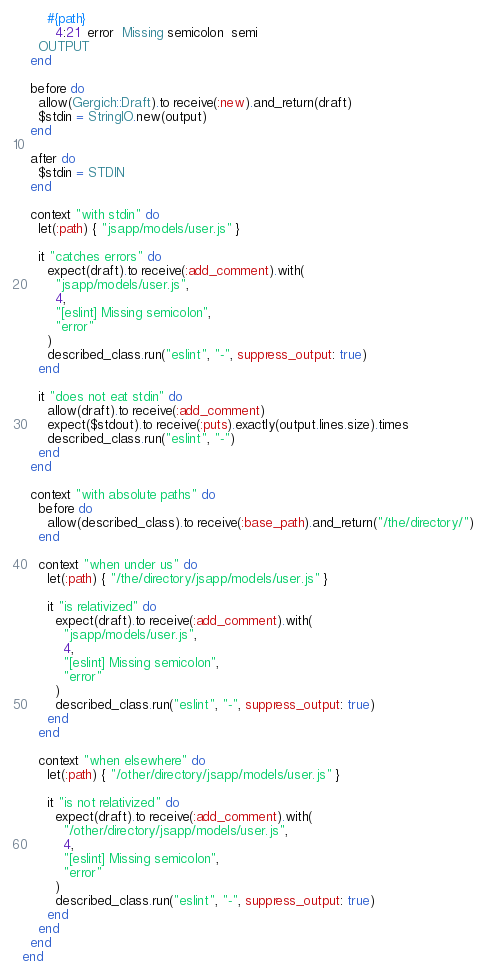<code> <loc_0><loc_0><loc_500><loc_500><_Ruby_>      #{path}
        4:21  error  Missing semicolon  semi
    OUTPUT
  end

  before do
    allow(Gergich::Draft).to receive(:new).and_return(draft)
    $stdin = StringIO.new(output)
  end

  after do
    $stdin = STDIN
  end

  context "with stdin" do
    let(:path) { "jsapp/models/user.js" }

    it "catches errors" do
      expect(draft).to receive(:add_comment).with(
        "jsapp/models/user.js",
        4,
        "[eslint] Missing semicolon",
        "error"
      )
      described_class.run("eslint", "-", suppress_output: true)
    end

    it "does not eat stdin" do
      allow(draft).to receive(:add_comment)
      expect($stdout).to receive(:puts).exactly(output.lines.size).times
      described_class.run("eslint", "-")
    end
  end

  context "with absolute paths" do
    before do
      allow(described_class).to receive(:base_path).and_return("/the/directory/")
    end

    context "when under us" do
      let(:path) { "/the/directory/jsapp/models/user.js" }

      it "is relativized" do
        expect(draft).to receive(:add_comment).with(
          "jsapp/models/user.js",
          4,
          "[eslint] Missing semicolon",
          "error"
        )
        described_class.run("eslint", "-", suppress_output: true)
      end
    end

    context "when elsewhere" do
      let(:path) { "/other/directory/jsapp/models/user.js" }

      it "is not relativized" do
        expect(draft).to receive(:add_comment).with(
          "/other/directory/jsapp/models/user.js",
          4,
          "[eslint] Missing semicolon",
          "error"
        )
        described_class.run("eslint", "-", suppress_output: true)
      end
    end
  end
end
</code> 